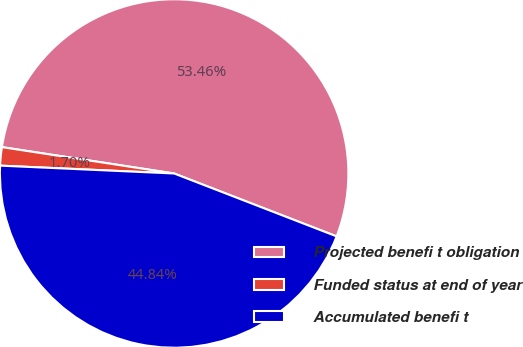<chart> <loc_0><loc_0><loc_500><loc_500><pie_chart><fcel>Projected benefi t obligation<fcel>Funded status at end of year<fcel>Accumulated benefi t<nl><fcel>53.46%<fcel>1.7%<fcel>44.84%<nl></chart> 